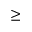Convert formula to latex. <formula><loc_0><loc_0><loc_500><loc_500>\geq</formula> 